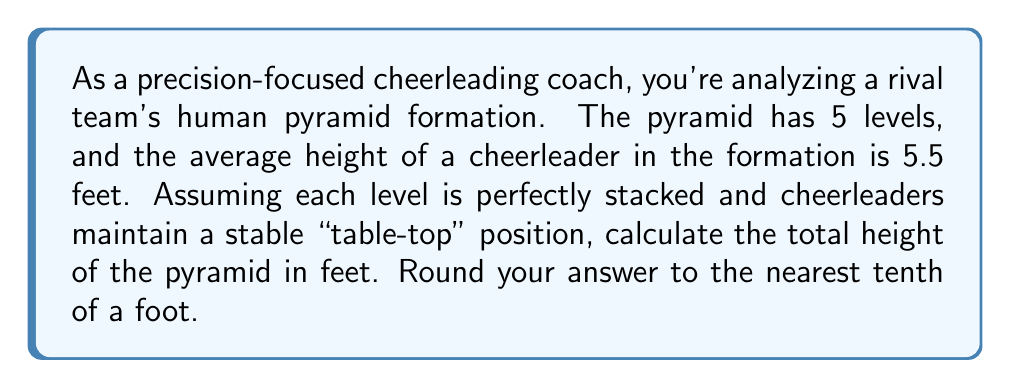Solve this math problem. To solve this problem, we need to understand the geometry of a human pyramid:

1) In a stable "table-top" position, a cheerleader's body forms a right triangle with the ground.

2) The hypotenuse of this triangle is approximately the cheerleader's height.

3) The height contribution of each level is the vertical component of this triangle.

Let's break it down step-by-step:

1) Let $h$ be the average cheerleader height (5.5 feet).

2) In a right triangle formed by a cheerleader's body:
   - Hypotenuse ≈ $h$
   - Base ≈ $\frac{2h}{3}$
   - Height ≈ $\frac{\sqrt{5}h}{3}$

3) We can derive this using the Pythagorean theorem:
   $$(\frac{2h}{3})^2 + (\frac{\sqrt{5}h}{3})^2 = h^2$$

4) The height contribution of each level is $\frac{\sqrt{5}h}{3}$

5) For a 5-level pyramid, the total height is:
   $$H = 5 \cdot \frac{\sqrt{5}h}{3}$$

6) Substituting $h = 5.5$:
   $$H = 5 \cdot \frac{\sqrt{5} \cdot 5.5}{3} \approx 20.5$$

7) Rounding to the nearest tenth: 20.5 feet
Answer: The total height of the 5-level human pyramid is approximately 20.5 feet. 